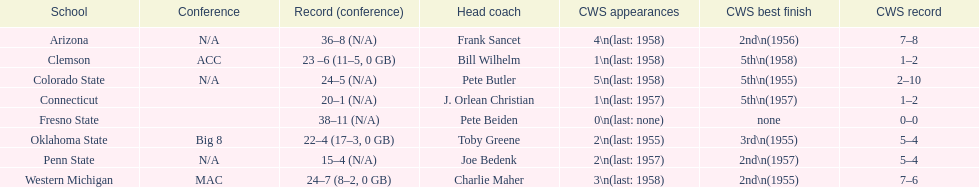What is the total number of college world series appearances by clemson? 1\n(last: 1958). What is the total number of college world series appearances by western michigan? 3\n(last: 1958). Among these two institutions, which one has a higher number of college world series appearances? Western Michigan. 